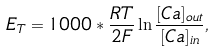<formula> <loc_0><loc_0><loc_500><loc_500>E _ { T } = 1 0 0 0 * \frac { R T } { 2 F } \ln \frac { [ C a ] _ { o u t } } { [ C a ] _ { i n } } ,</formula> 